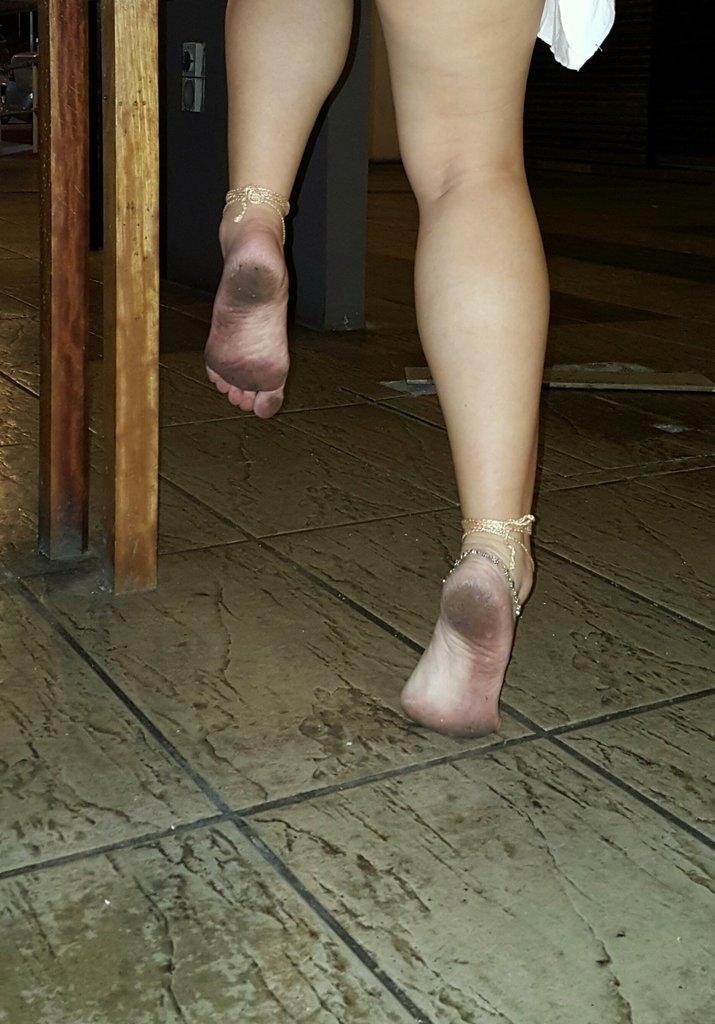What body part of a woman is visible in the image? There are a woman's legs visible in the image. What type of accessory is the woman wearing on her legs? The woman is wearing anklets in the image. What material are the poles made of in the image? The wooden poles are made of wood in the image. How does the woman use magic to entertain the visitor in the image? There is no mention of magic, a visitor, or any form of entertainment in the image. 